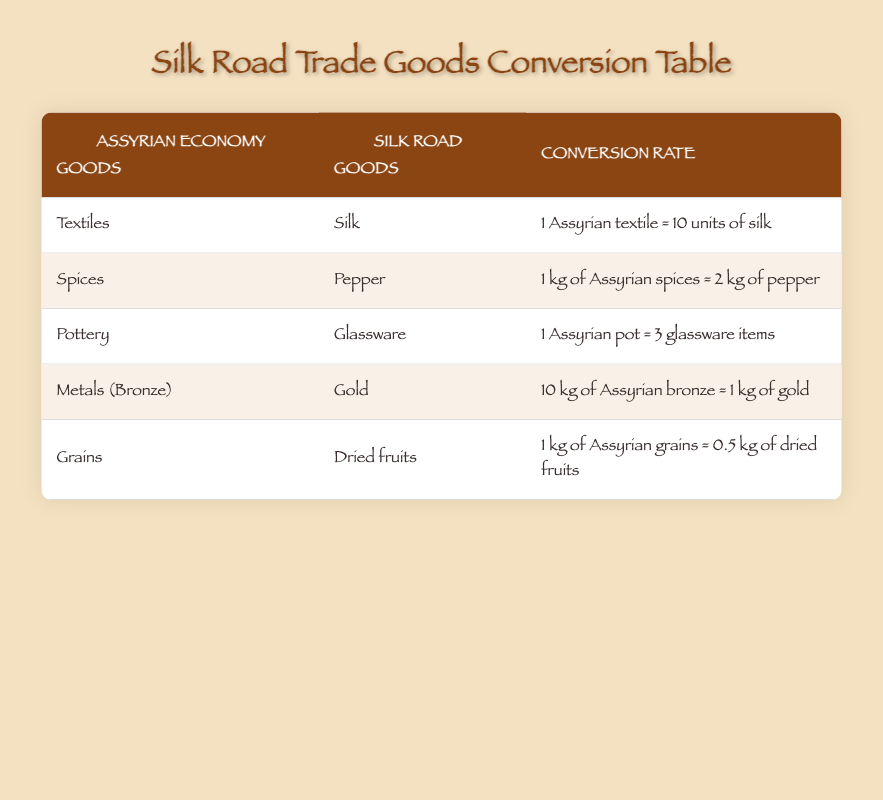What goods can be exchanged for textiles in the Assyrian economy? According to the table, textiles from the Assyrian economy can be exchanged for silk, specifically at the rate of 1 Assyrian textile equating to 10 units of silk.
Answer: Silk How many glassware items can be obtained from one Assyrian pot? The table states that one Assyrian pot can be exchanged for 3 glassware items.
Answer: 3 glassware items Is it true that 1 kg of Assyrian spices equals more than 1 kg of pepper? The table shows that 1 kg of Assyrian spices equals 2 kg of pepper, which is indeed greater than 1 kg.
Answer: Yes What is the conversion rate of Assyrian bronze to gold? The conversion rate in the table indicates that 10 kg of Assyrian bronze is equivalent to 1 kg of gold.
Answer: 10 kg of Assyrian bronze = 1 kg of gold If a trader has 4 kg of Assyrian grains, how many kg of dried fruits can they obtain? The conversion rate indicates that 1 kg of Assyrian grains equals 0.5 kg of dried fruits. Therefore, 4 kg of Assyrian grains can be converted as follows: 4 kg × 0.5 kg = 2 kg of dried fruits.
Answer: 2 kg of dried fruits 